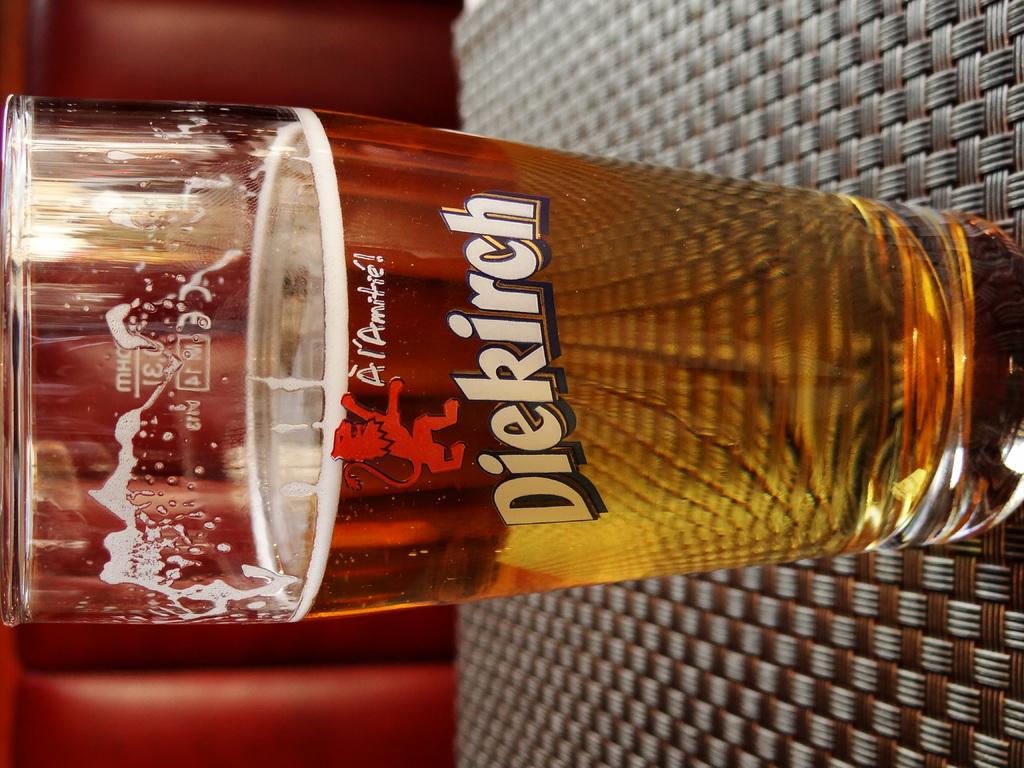What is the brand of beer?
Provide a succinct answer. Diekirch. 